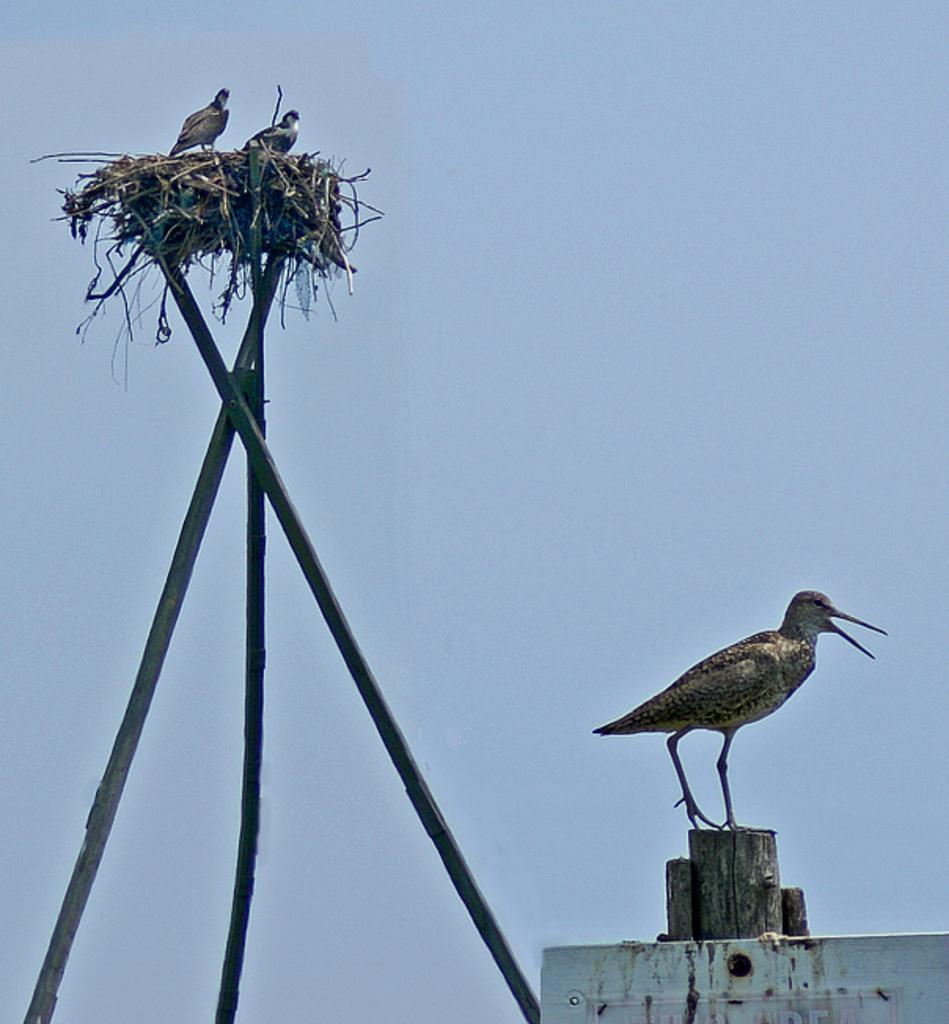What type of animals can be seen in the image? There are birds in the image. Where are the birds located in the image? Some birds are in a nest, and there is also a bird on a wooden pole. What color is the sky in the image? The sky is blue in the image. What type of dirt can be seen on the earth in the image? There is no dirt or earth present in the image; it features birds in a nest and on a wooden pole, with a blue sky in the background. 